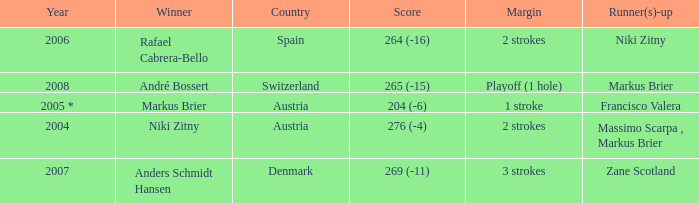Who was the runner-up when the margin was 1 stroke? Francisco Valera. 